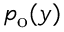<formula> <loc_0><loc_0><loc_500><loc_500>p _ { o } ( y )</formula> 